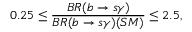Convert formula to latex. <formula><loc_0><loc_0><loc_500><loc_500>0 . 2 5 \leq \frac { B R ( b \rightarrow s \gamma ) } { B R ( b \rightarrow s \gamma ) ( S M ) } \leq 2 . 5 ,</formula> 